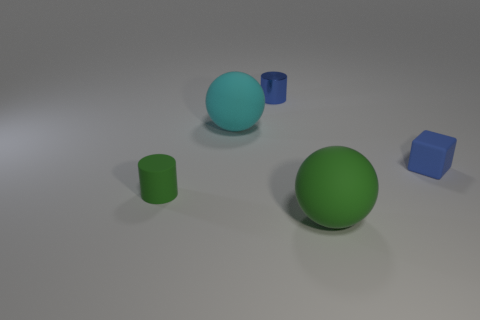There is a small rubber thing that is the same color as the shiny cylinder; what is its shape?
Give a very brief answer. Cube. Are there any small yellow objects made of the same material as the blue cylinder?
Offer a terse response. No. What shape is the rubber object that is left of the blue rubber block and behind the small green rubber cylinder?
Make the answer very short. Sphere. What number of other things are the same shape as the large green rubber thing?
Provide a succinct answer. 1. The block is what size?
Your response must be concise. Small. How many objects are tiny green cylinders or small blue rubber cubes?
Make the answer very short. 2. What is the size of the blue thing behind the small cube?
Offer a very short reply. Small. Is there any other thing that has the same size as the metallic cylinder?
Provide a short and direct response. Yes. The object that is in front of the cyan rubber object and on the left side of the blue cylinder is what color?
Your answer should be compact. Green. Does the blue thing to the right of the small shiny cylinder have the same material as the tiny green object?
Make the answer very short. Yes. 